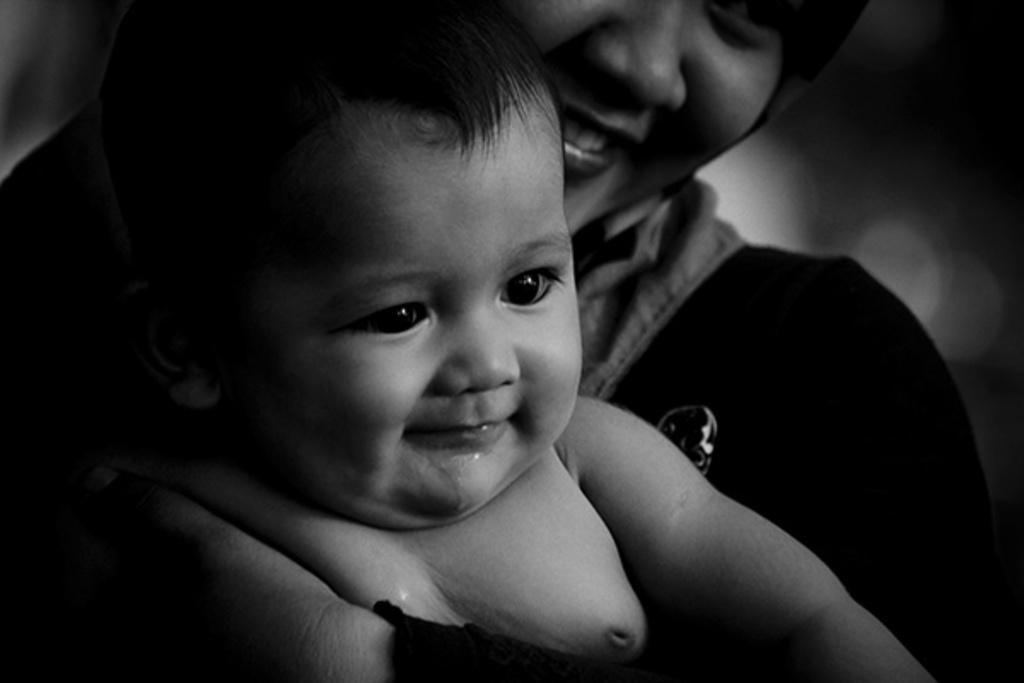How would you summarize this image in a sentence or two? This is a black and white picture. Here we can see a person holding a baby. 